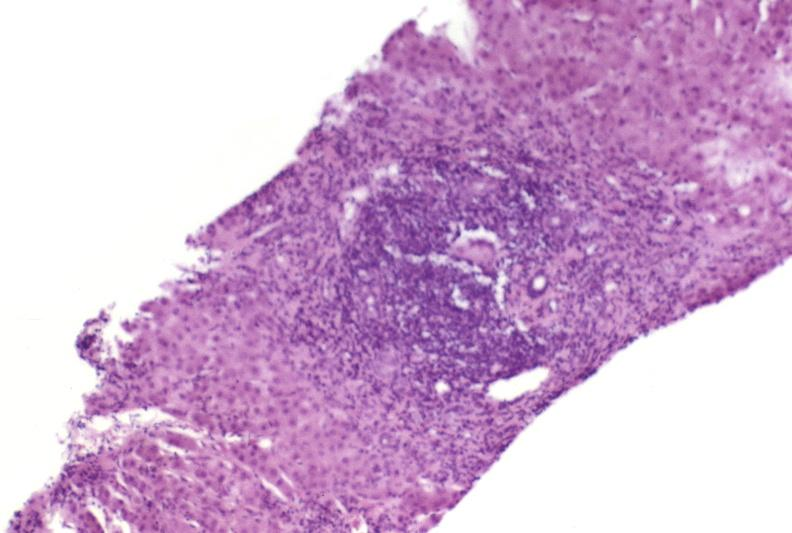does amyloidosis show autoimmune hepatitis?
Answer the question using a single word or phrase. No 